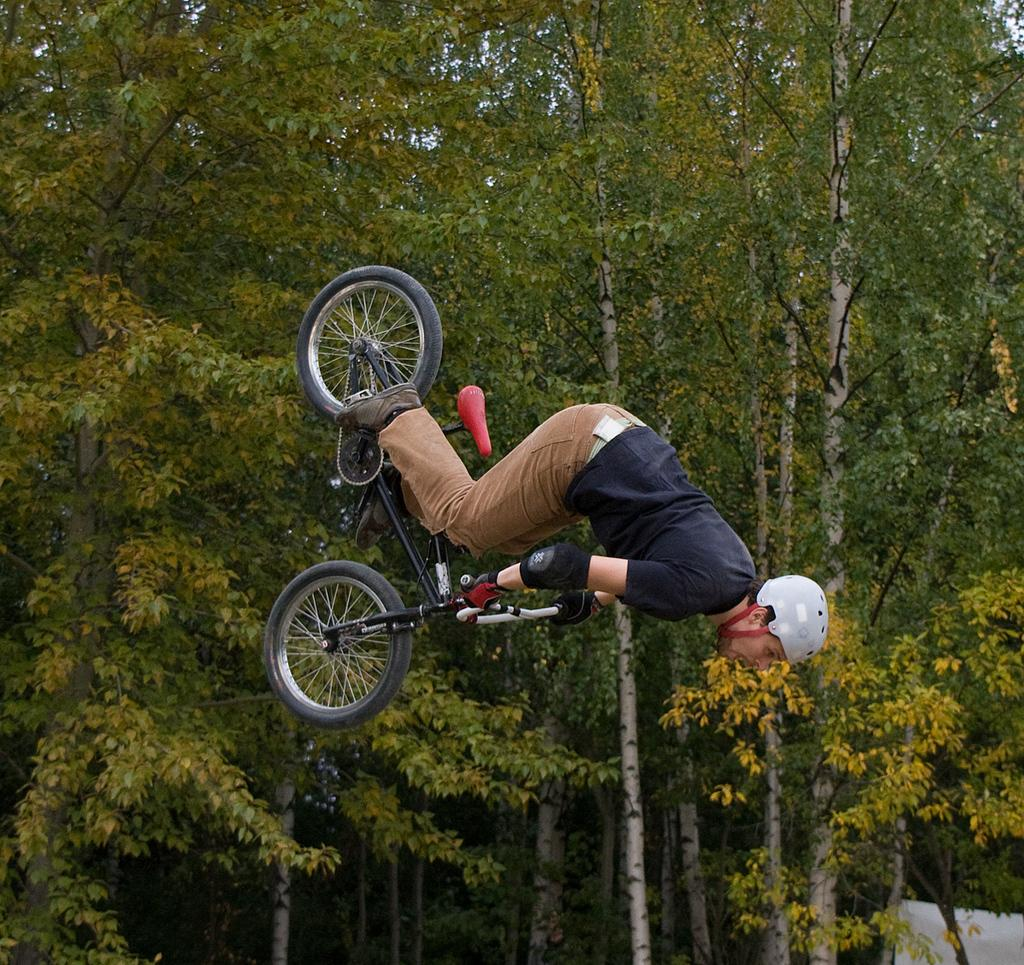What is the main subject of the image? There is a man in the image. What is the man doing in the image? The man is jumping while holding a bicycle with his hands. What can be seen in the background of the image? There are trees visible in the image. What type of weather can be seen in the image? The provided facts do not mention any weather conditions, so it cannot be determined from the image. 